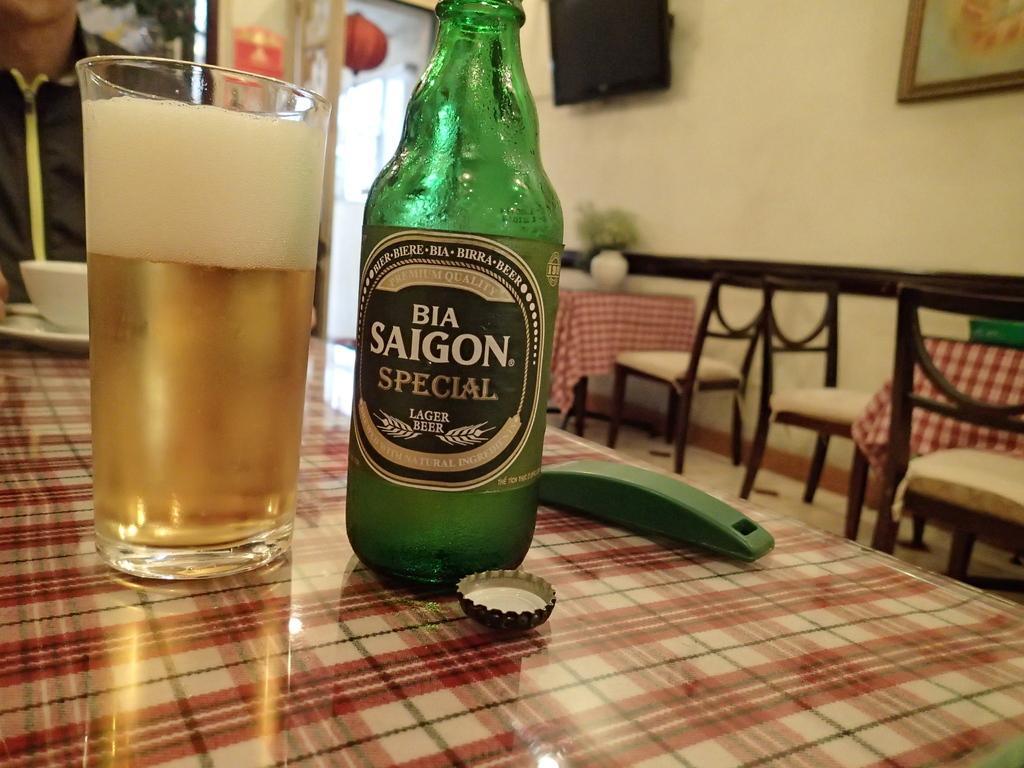How would you summarize this image in a sentence or two? In this image i can see a beer bottle, glass with beer in it, bottle cap and bottle opener. In the background i can see chairs, a flower pot, a television, a wall, a photo frame attached to the wall and a person. 